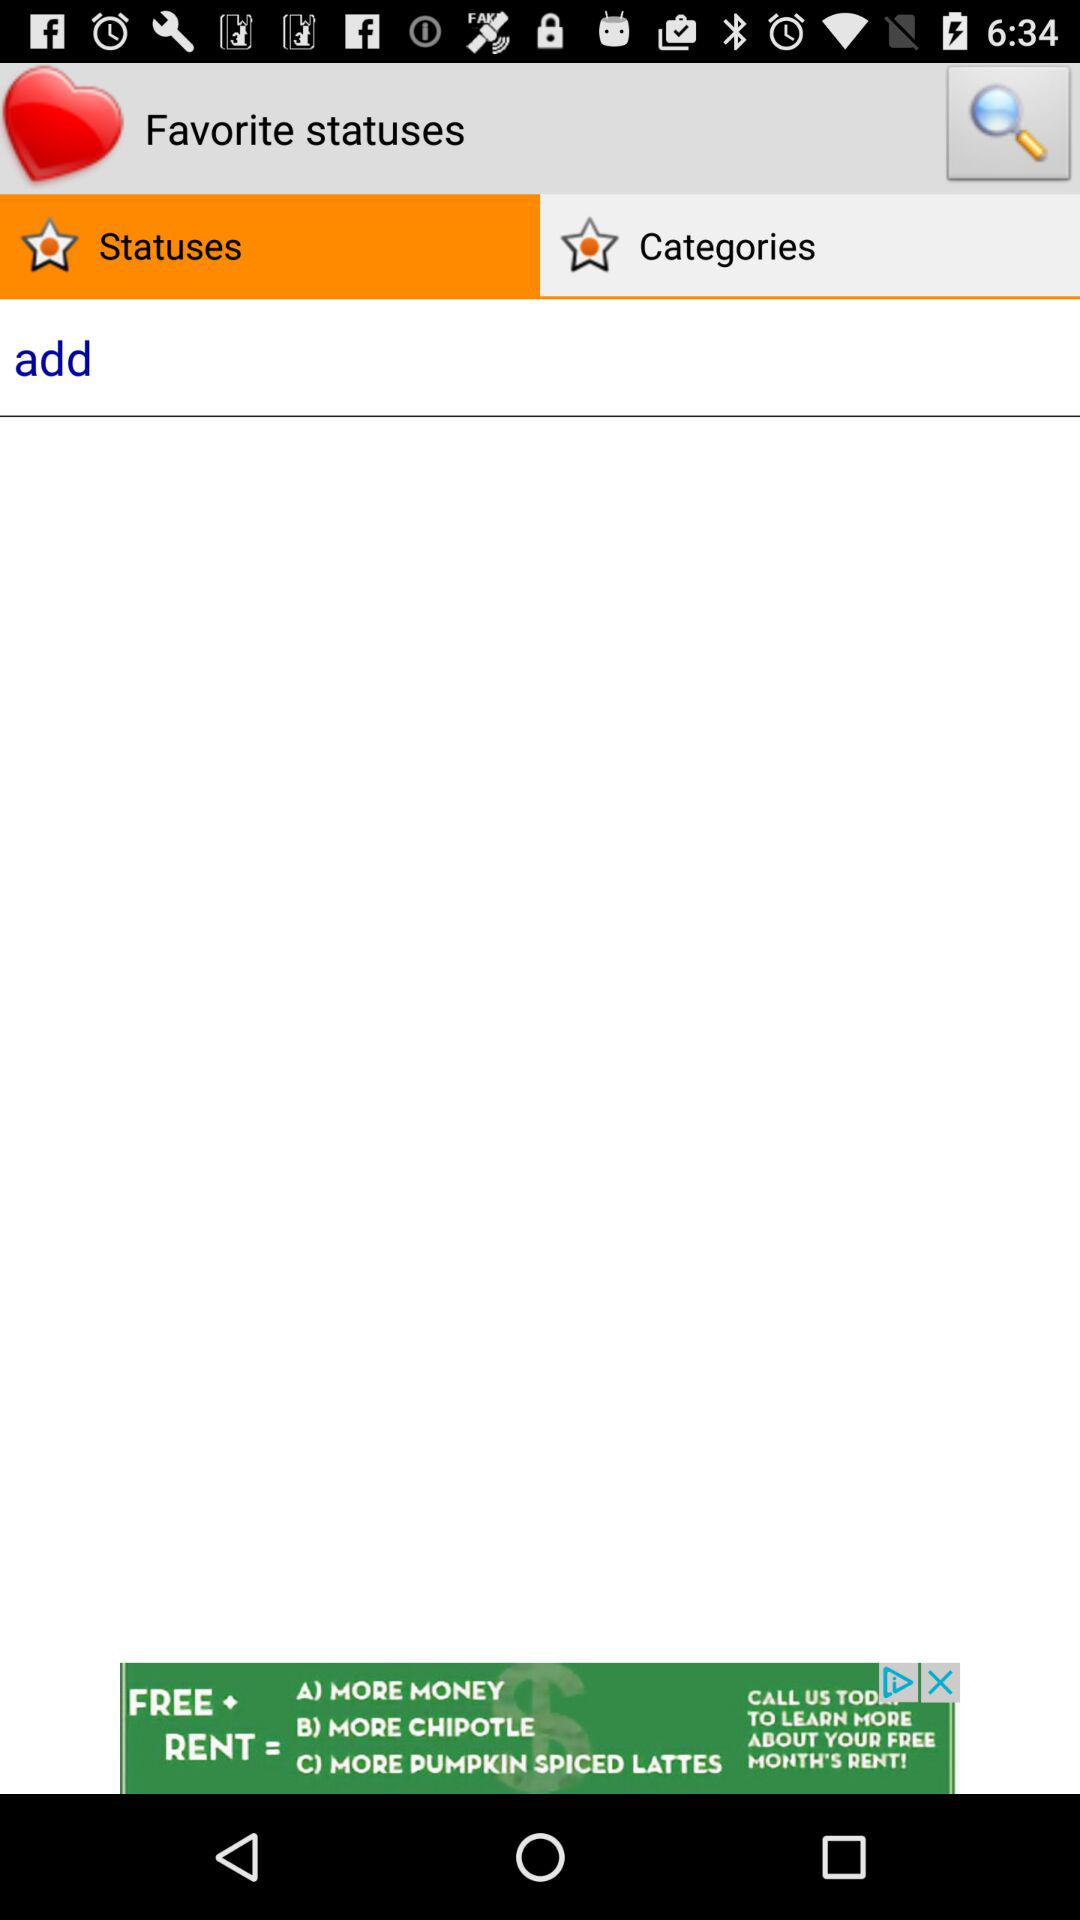Which tab is selected? The selected tab is "Statuses". 